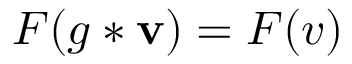Convert formula to latex. <formula><loc_0><loc_0><loc_500><loc_500>F ( g * v ) = F ( v )</formula> 